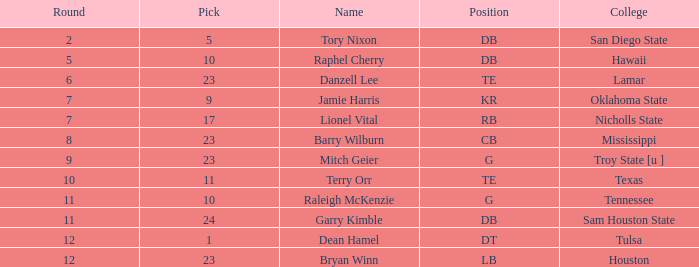For raleigh mckenzie, which is the top overall with a pick larger than 10? None. 